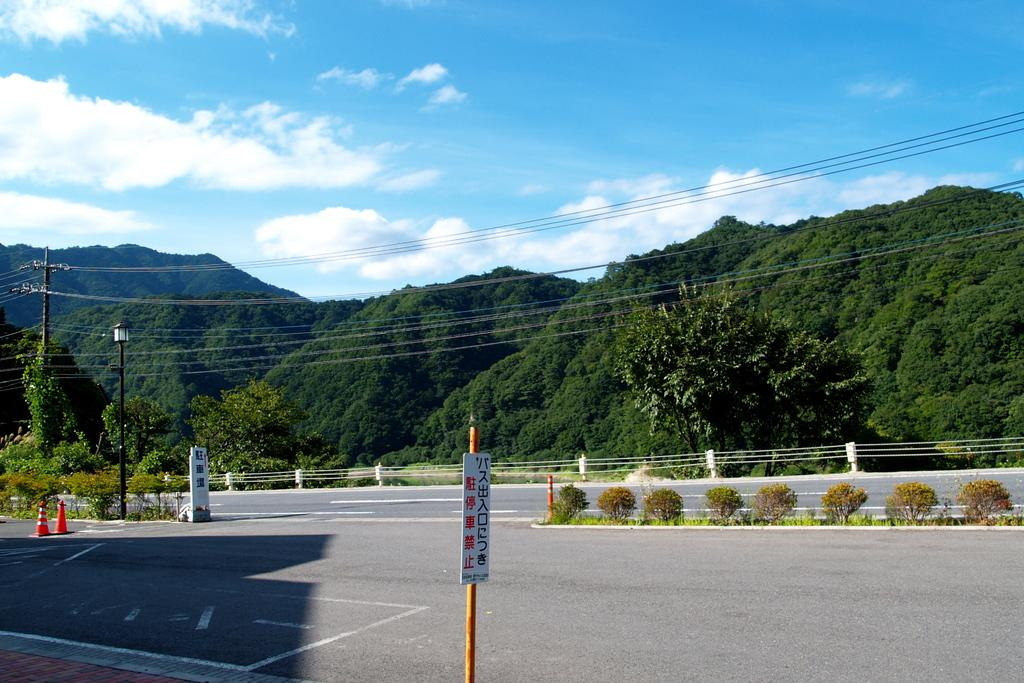What is the main object in the image? There is a sign board in the image. What other objects can be seen in the image? Traffic cones, plants, trees, hills, a street lamp, and a current pole are visible in the image. What is the condition of the sky in the image? The sky is visible in the image, and clouds are present. What is the reason for the governor's debt in the image? There is no governor or debt mentioned in the image; it only contains a sign board, traffic cones, plants, trees, hills, a street lamp, a current pole, and a sky with clouds. 